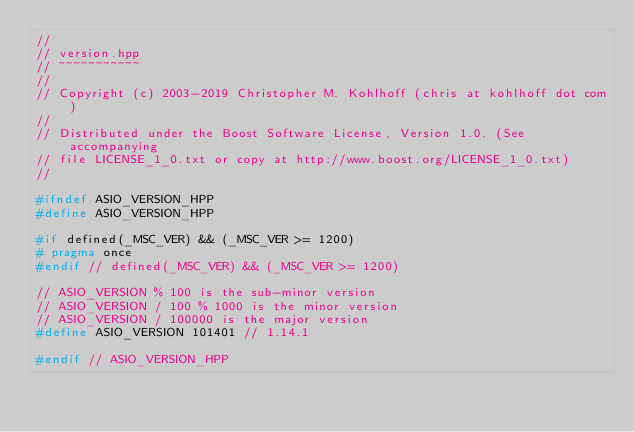Convert code to text. <code><loc_0><loc_0><loc_500><loc_500><_C++_>//
// version.hpp
// ~~~~~~~~~~~
//
// Copyright (c) 2003-2019 Christopher M. Kohlhoff (chris at kohlhoff dot com)
//
// Distributed under the Boost Software License, Version 1.0. (See accompanying
// file LICENSE_1_0.txt or copy at http://www.boost.org/LICENSE_1_0.txt)
//

#ifndef ASIO_VERSION_HPP
#define ASIO_VERSION_HPP

#if defined(_MSC_VER) && (_MSC_VER >= 1200)
# pragma once
#endif // defined(_MSC_VER) && (_MSC_VER >= 1200)

// ASIO_VERSION % 100 is the sub-minor version
// ASIO_VERSION / 100 % 1000 is the minor version
// ASIO_VERSION / 100000 is the major version
#define ASIO_VERSION 101401 // 1.14.1

#endif // ASIO_VERSION_HPP
</code> 